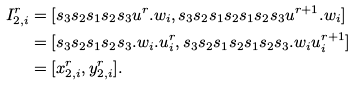<formula> <loc_0><loc_0><loc_500><loc_500>I _ { 2 , i } ^ { r } & = [ s _ { 3 } s _ { 2 } s _ { 1 } s _ { 2 } s _ { 3 } u ^ { r } . w _ { i } , s _ { 3 } s _ { 2 } s _ { 1 } s _ { 2 } s _ { 1 } s _ { 2 } s _ { 3 } u ^ { r + 1 } . w _ { i } ] \\ & = [ s _ { 3 } s _ { 2 } s _ { 1 } s _ { 2 } s _ { 3 } . w _ { i } . u _ { i } ^ { r } , s _ { 3 } s _ { 2 } s _ { 1 } s _ { 2 } s _ { 1 } s _ { 2 } s _ { 3 } . w _ { i } u _ { i } ^ { r + 1 } ] \\ & = [ x _ { 2 , i } ^ { r } , y _ { 2 , i } ^ { r } ] .</formula> 